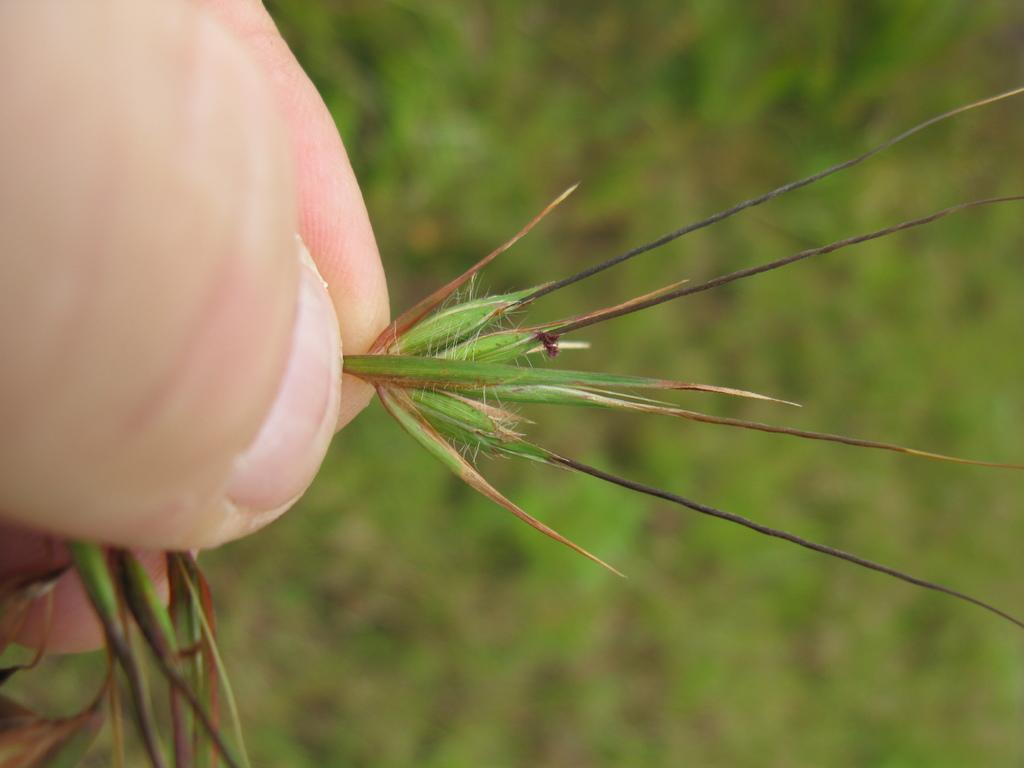What is the person's hand holding in the image? There is a person's hand holding a plant in the image. Can you describe the background of the image? The background of the image is blurred. What type of shoe is visible in the image? There is no shoe present in the image; it features a person's hand holding a plant with a blurred background. 